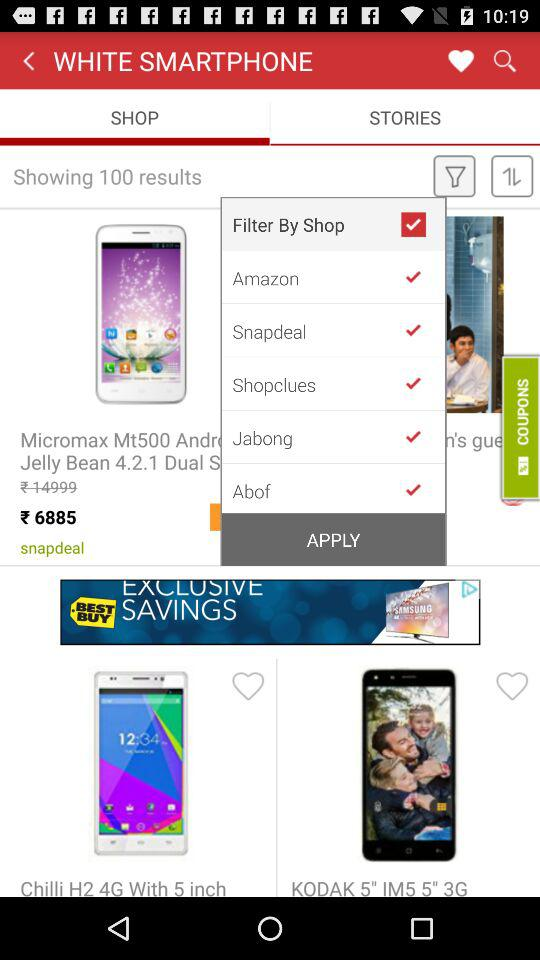What is the discounted price of the "Micromax Mt500 Android"? The discounted price of the "Micromax Mt500 Android" is 6885 rupees. 